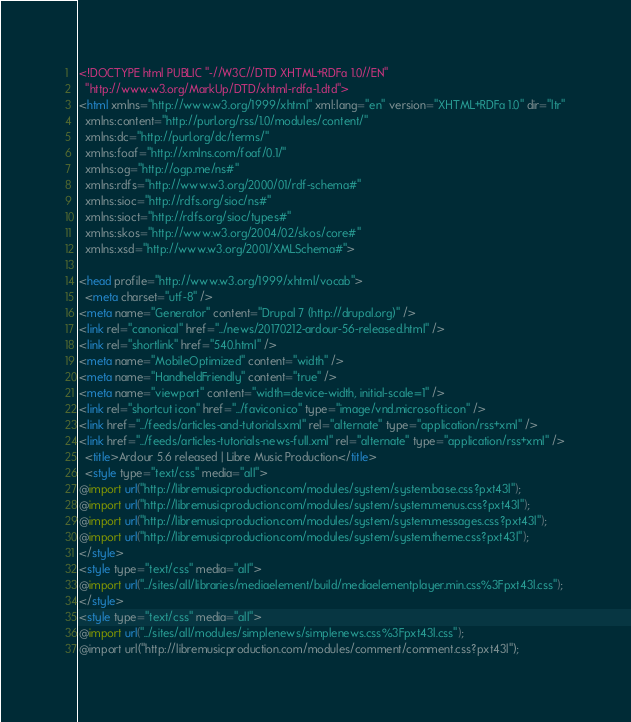<code> <loc_0><loc_0><loc_500><loc_500><_HTML_><!DOCTYPE html PUBLIC "-//W3C//DTD XHTML+RDFa 1.0//EN"
  "http://www.w3.org/MarkUp/DTD/xhtml-rdfa-1.dtd">
<html xmlns="http://www.w3.org/1999/xhtml" xml:lang="en" version="XHTML+RDFa 1.0" dir="ltr"
  xmlns:content="http://purl.org/rss/1.0/modules/content/"
  xmlns:dc="http://purl.org/dc/terms/"
  xmlns:foaf="http://xmlns.com/foaf/0.1/"
  xmlns:og="http://ogp.me/ns#"
  xmlns:rdfs="http://www.w3.org/2000/01/rdf-schema#"
  xmlns:sioc="http://rdfs.org/sioc/ns#"
  xmlns:sioct="http://rdfs.org/sioc/types#"
  xmlns:skos="http://www.w3.org/2004/02/skos/core#"
  xmlns:xsd="http://www.w3.org/2001/XMLSchema#">

<head profile="http://www.w3.org/1999/xhtml/vocab">
  <meta charset="utf-8" />
<meta name="Generator" content="Drupal 7 (http://drupal.org)" />
<link rel="canonical" href="../news/20170212-ardour-56-released.html" />
<link rel="shortlink" href="540.html" />
<meta name="MobileOptimized" content="width" />
<meta name="HandheldFriendly" content="true" />
<meta name="viewport" content="width=device-width, initial-scale=1" />
<link rel="shortcut icon" href="../favicon.ico" type="image/vnd.microsoft.icon" />
<link href="../feeds/articles-and-tutorials.xml" rel="alternate" type="application/rss+xml" />
<link href="../feeds/articles-tutorials-news-full.xml" rel="alternate" type="application/rss+xml" />
  <title>Ardour 5.6 released | Libre Music Production</title>
  <style type="text/css" media="all">
@import url("http://libremusicproduction.com/modules/system/system.base.css?pxt43l");
@import url("http://libremusicproduction.com/modules/system/system.menus.css?pxt43l");
@import url("http://libremusicproduction.com/modules/system/system.messages.css?pxt43l");
@import url("http://libremusicproduction.com/modules/system/system.theme.css?pxt43l");
</style>
<style type="text/css" media="all">
@import url("../sites/all/libraries/mediaelement/build/mediaelementplayer.min.css%3Fpxt43l.css");
</style>
<style type="text/css" media="all">
@import url("../sites/all/modules/simplenews/simplenews.css%3Fpxt43l.css");
@import url("http://libremusicproduction.com/modules/comment/comment.css?pxt43l");</code> 